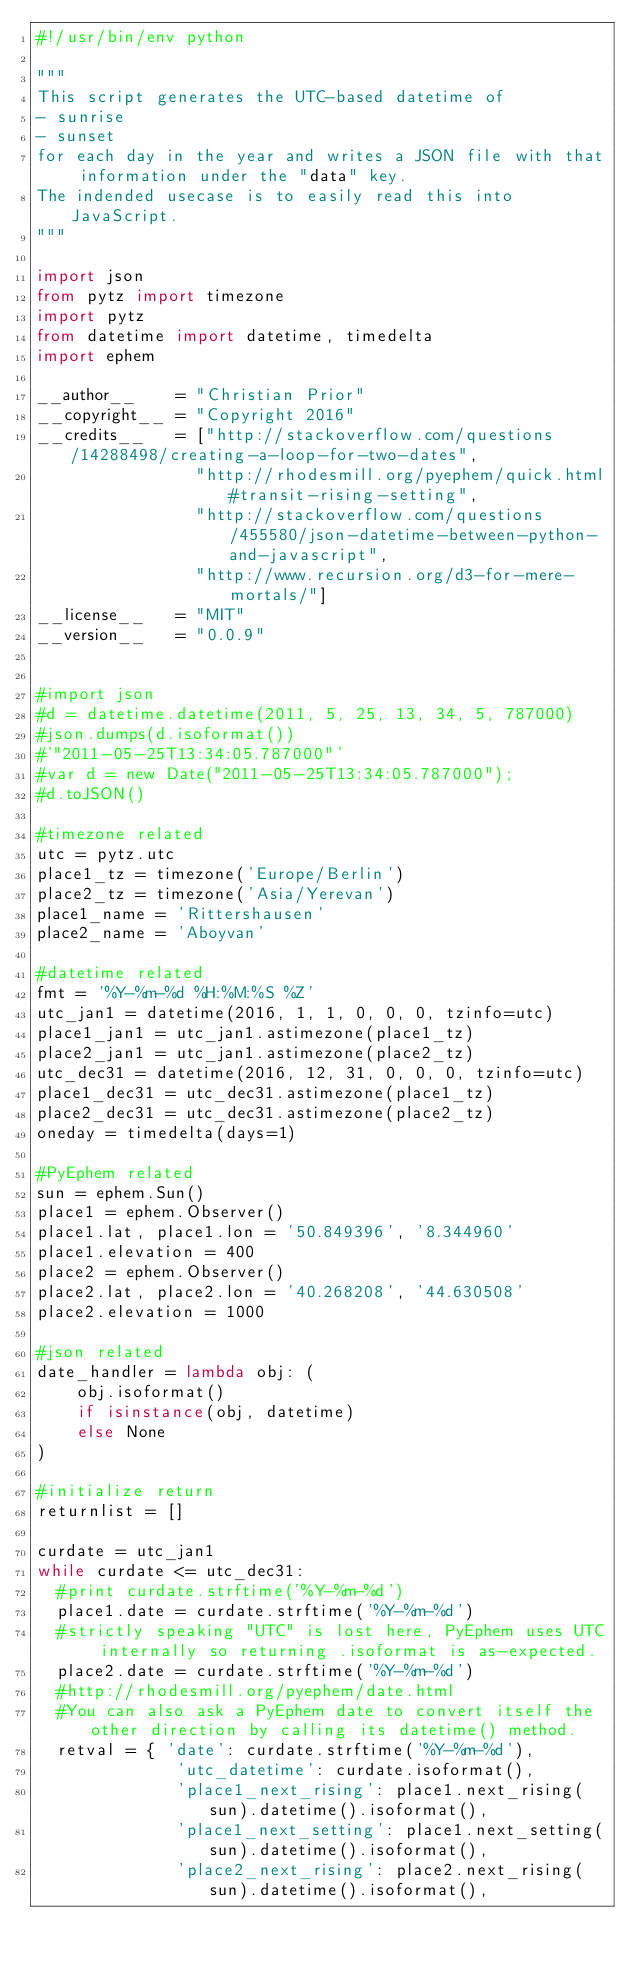<code> <loc_0><loc_0><loc_500><loc_500><_Python_>#!/usr/bin/env python

"""
This script generates the UTC-based datetime of
- sunrise
- sunset
for each day in the year and writes a JSON file with that information under the "data" key.
The indended usecase is to easily read this into JavaScript.
"""

import json
from pytz import timezone
import pytz
from datetime import datetime, timedelta
import ephem

__author__    = "Christian Prior"
__copyright__ = "Copyright 2016"
__credits__   = ["http://stackoverflow.com/questions/14288498/creating-a-loop-for-two-dates",
                "http://rhodesmill.org/pyephem/quick.html#transit-rising-setting",
                "http://stackoverflow.com/questions/455580/json-datetime-between-python-and-javascript",
                "http://www.recursion.org/d3-for-mere-mortals/"]
__license__   = "MIT"
__version__   = "0.0.9"


#import json
#d = datetime.datetime(2011, 5, 25, 13, 34, 5, 787000)
#json.dumps(d.isoformat())
#'"2011-05-25T13:34:05.787000"'
#var d = new Date("2011-05-25T13:34:05.787000");
#d.toJSON()

#timezone related
utc = pytz.utc
place1_tz = timezone('Europe/Berlin')
place2_tz = timezone('Asia/Yerevan')
place1_name = 'Rittershausen'
place2_name = 'Aboyvan'

#datetime related
fmt = '%Y-%m-%d %H:%M:%S %Z'
utc_jan1 = datetime(2016, 1, 1, 0, 0, 0, tzinfo=utc)
place1_jan1 = utc_jan1.astimezone(place1_tz)
place2_jan1 = utc_jan1.astimezone(place2_tz)
utc_dec31 = datetime(2016, 12, 31, 0, 0, 0, tzinfo=utc)
place1_dec31 = utc_dec31.astimezone(place1_tz)
place2_dec31 = utc_dec31.astimezone(place2_tz)
oneday = timedelta(days=1)

#PyEphem related
sun = ephem.Sun()
place1 = ephem.Observer()
place1.lat, place1.lon = '50.849396', '8.344960'
place1.elevation = 400
place2 = ephem.Observer()
place2.lat, place2.lon = '40.268208', '44.630508'
place2.elevation = 1000

#json related
date_handler = lambda obj: (
    obj.isoformat()
    if isinstance(obj, datetime)
    else None
)

#initialize return
returnlist = []

curdate = utc_jan1
while curdate <= utc_dec31:
  #print curdate.strftime('%Y-%m-%d')
  place1.date = curdate.strftime('%Y-%m-%d')
  #strictly speaking "UTC" is lost here, PyEphem uses UTC internally so returning .isoformat is as-expected.
  place2.date = curdate.strftime('%Y-%m-%d')
  #http://rhodesmill.org/pyephem/date.html
  #You can also ask a PyEphem date to convert itself the other direction by calling its datetime() method.
  retval = { 'date': curdate.strftime('%Y-%m-%d'),
              'utc_datetime': curdate.isoformat(),
              'place1_next_rising': place1.next_rising(sun).datetime().isoformat(),
              'place1_next_setting': place1.next_setting(sun).datetime().isoformat(),
              'place2_next_rising': place2.next_rising(sun).datetime().isoformat(),</code> 